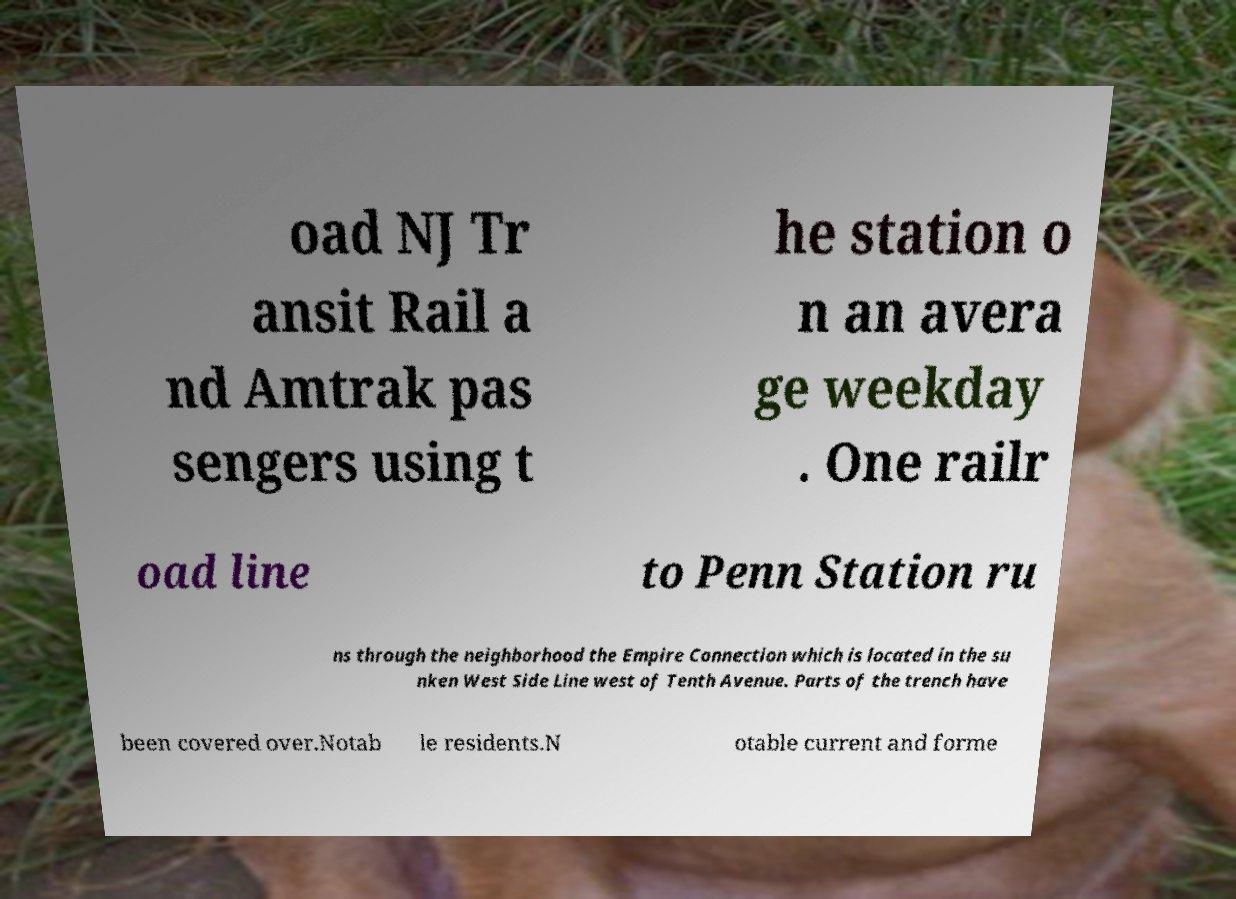I need the written content from this picture converted into text. Can you do that? oad NJ Tr ansit Rail a nd Amtrak pas sengers using t he station o n an avera ge weekday . One railr oad line to Penn Station ru ns through the neighborhood the Empire Connection which is located in the su nken West Side Line west of Tenth Avenue. Parts of the trench have been covered over.Notab le residents.N otable current and forme 